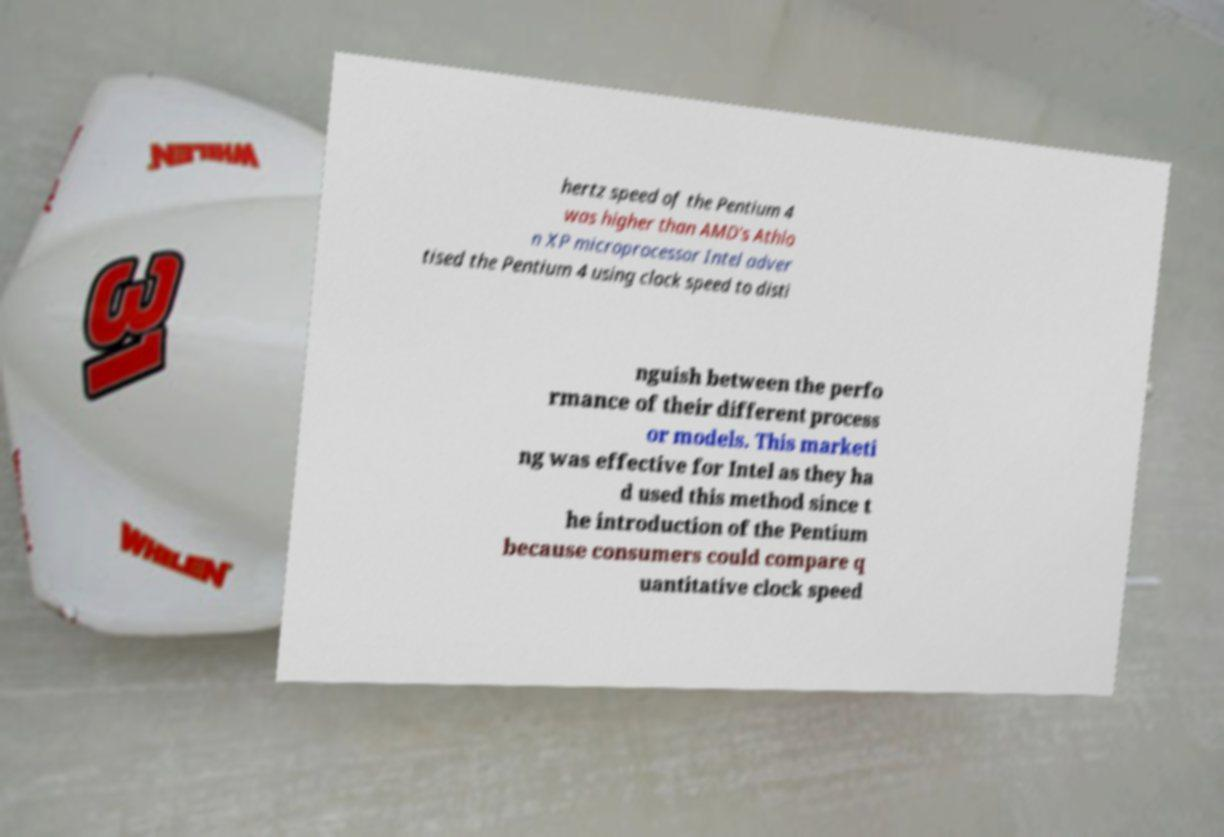Could you extract and type out the text from this image? hertz speed of the Pentium 4 was higher than AMD's Athlo n XP microprocessor Intel adver tised the Pentium 4 using clock speed to disti nguish between the perfo rmance of their different process or models. This marketi ng was effective for Intel as they ha d used this method since t he introduction of the Pentium because consumers could compare q uantitative clock speed 